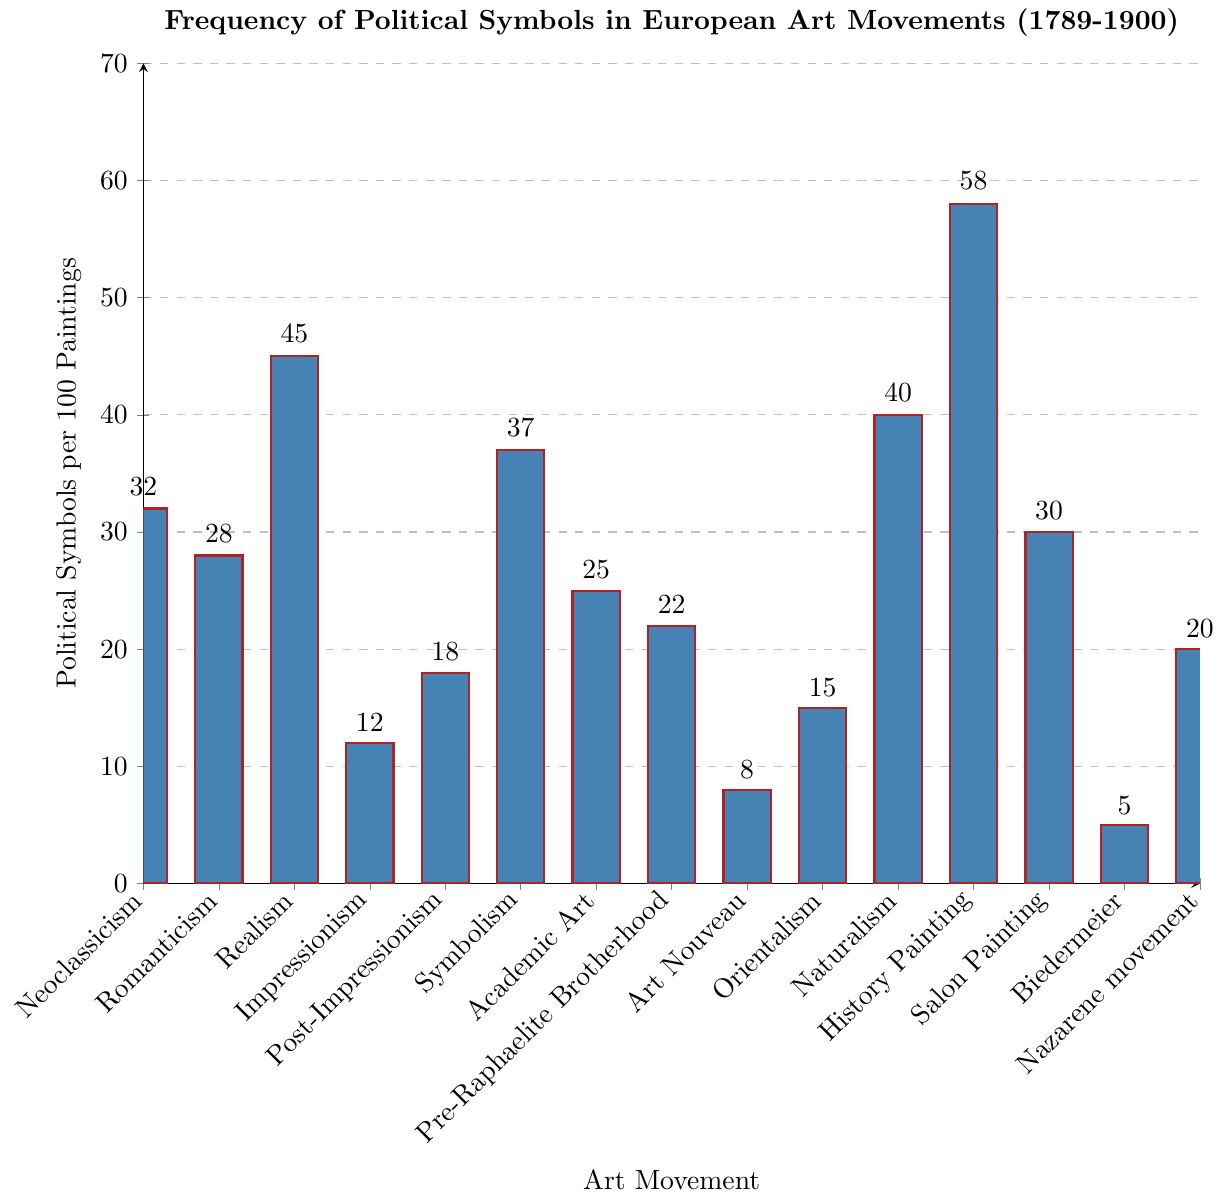What is the movement with the highest frequency of political symbols per 100 paintings? To find the answer, look at the tallest bar in the bar chart which represents the highest frequency.
Answer: History Painting Which two movements have the closest frequency of political symbols per 100 paintings? Compare the heights of the bars to find the two bars that are nearest in height.
Answer: Academic Art and Salon Painting How many movements have more than 30 political symbols per 100 paintings? Count the number of bars that exceed the height corresponding to 30 on the y-axis.
Answer: Four What is the difference in the frequency of political symbols between Realism and Impressionism? Subtract the height of the Impressionism bar from the height of the Realism bar: 45 - 12 = 33.
Answer: 33 Which movement has the lowest frequency of political symbols, and what is that number? Find the shortest bar representing the lowest frequency.
Answer: Biedermeier, 5 By how much does the frequency of political symbols in Symbolism exceed that in Post-Impressionism? Subtract the height of the Post-Impressionism bar from the height of the Symbolism bar: 37 - 18 = 19.
Answer: 19 What is the average frequency of political symbols per 100 paintings across all movements? Sum all values and divide by the number of movements: (32 + 28 + 45 + 12 + 18 + 37 + 25 + 22 + 8 + 15 + 40 + 58 + 30 + 5 + 20)/15 = 29.33.
Answer: 29.33 Which movement has slightly fewer political symbols per 100 paintings than Romanticism? Compare the bar heights to find the one immediately less than the Romanticism bar (28).
Answer: Academic Art Is the frequency of political symbols in Naturalism closer to that in Symbolism or Realism? Compare the difference between Naturalism and the two other movements:
Answer: Symbolism How many movements have a frequency of political symbols that is less than 20 per 100 paintings? Count the number of bars that are below the height corresponding to 20 on the y-axis.
Answer: Five 